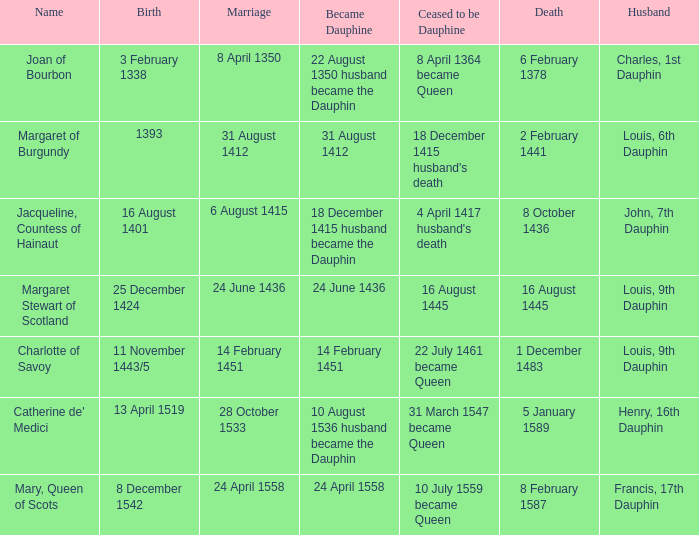When was the death of the person with husband charles, 1st dauphin? 6 February 1378. 